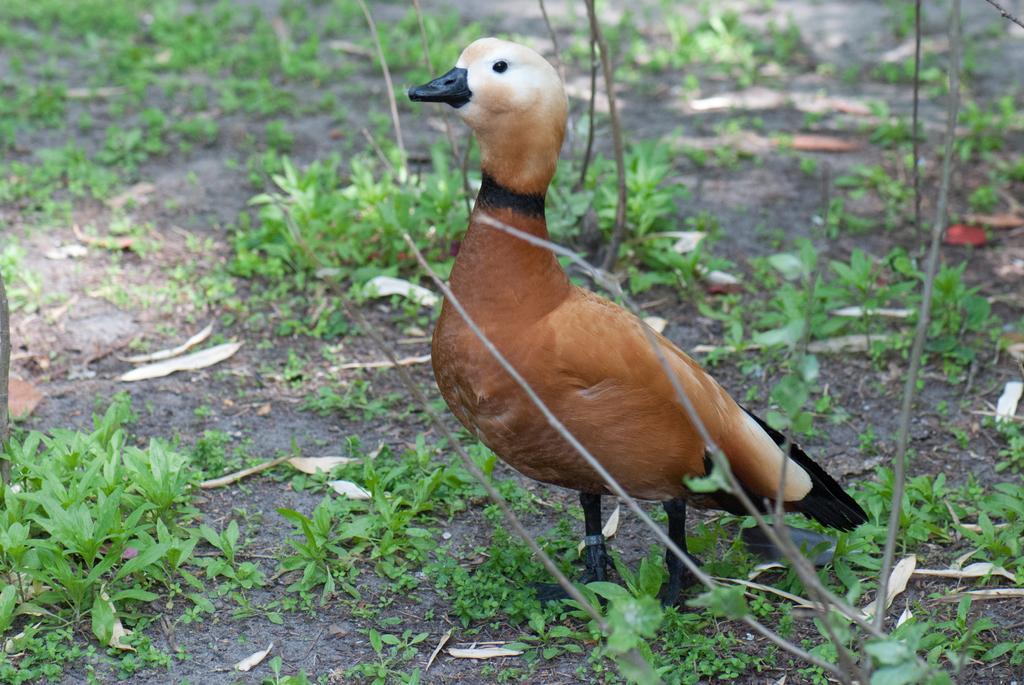Could you give a brief overview of what you see in this image? In this image, we can see a duck which is colored brown. There are some plants on the ground. 